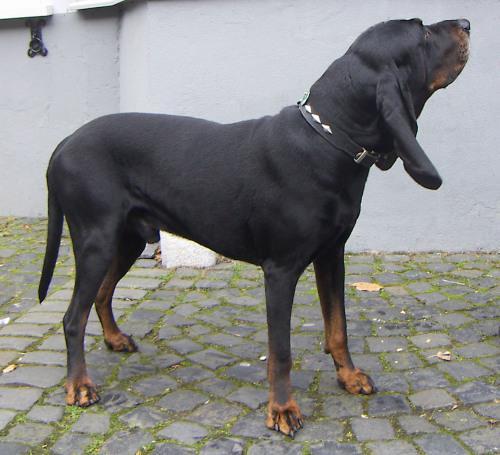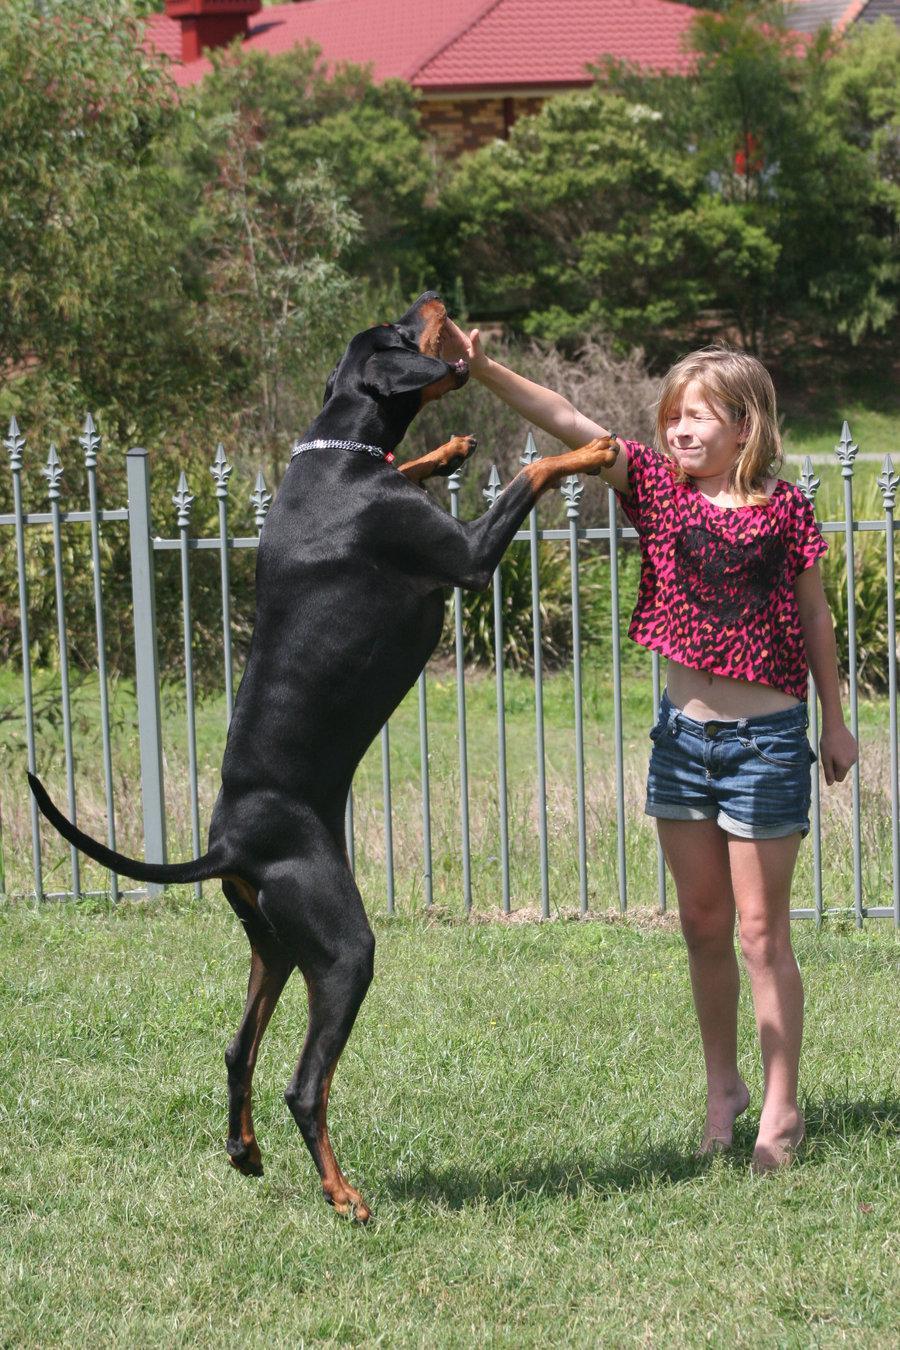The first image is the image on the left, the second image is the image on the right. For the images shown, is this caption "Each image shows one dog standing in profile, and the left image shows a brown dog, while the right image shows a right-facing doberman with pointy ears and docked tail." true? Answer yes or no. No. The first image is the image on the left, the second image is the image on the right. Considering the images on both sides, is "At least one dog is facing towards the left." valid? Answer yes or no. No. 